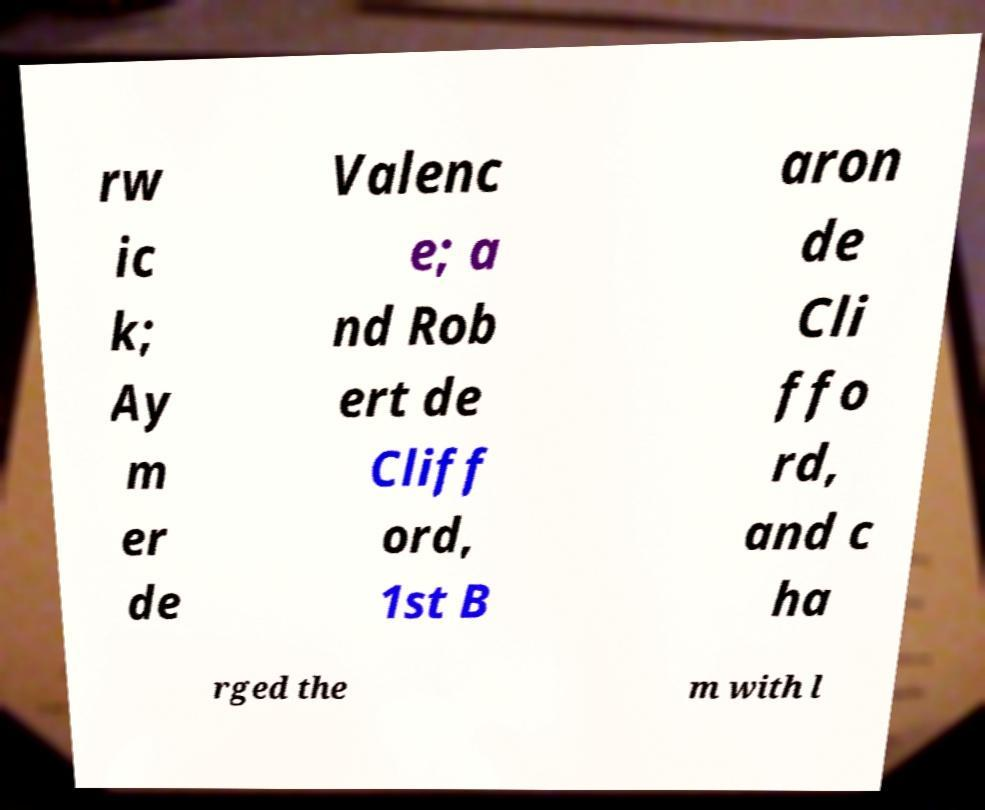Could you assist in decoding the text presented in this image and type it out clearly? rw ic k; Ay m er de Valenc e; a nd Rob ert de Cliff ord, 1st B aron de Cli ffo rd, and c ha rged the m with l 